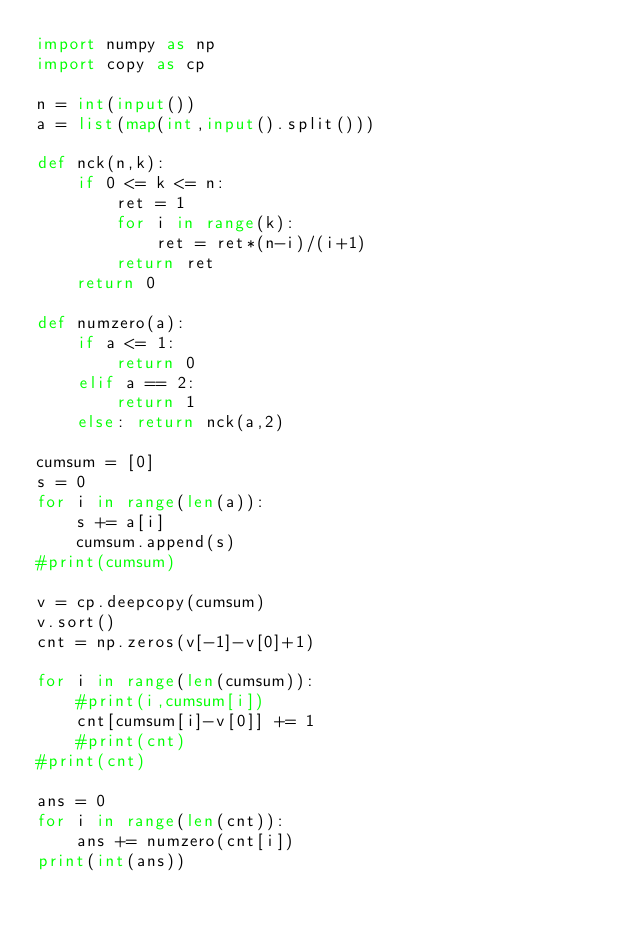Convert code to text. <code><loc_0><loc_0><loc_500><loc_500><_Python_>import numpy as np
import copy as cp

n = int(input())
a = list(map(int,input().split()))

def nck(n,k):
    if 0 <= k <= n:
        ret = 1
        for i in range(k):
            ret = ret*(n-i)/(i+1)
        return ret
    return 0

def numzero(a):
    if a <= 1:
        return 0
    elif a == 2:
        return 1
    else: return nck(a,2)

cumsum = [0]
s = 0
for i in range(len(a)):
    s += a[i]
    cumsum.append(s)
#print(cumsum)

v = cp.deepcopy(cumsum)
v.sort()
cnt = np.zeros(v[-1]-v[0]+1)

for i in range(len(cumsum)):
    #print(i,cumsum[i])
    cnt[cumsum[i]-v[0]] += 1
    #print(cnt)
#print(cnt)

ans = 0
for i in range(len(cnt)):
    ans += numzero(cnt[i])
print(int(ans))</code> 